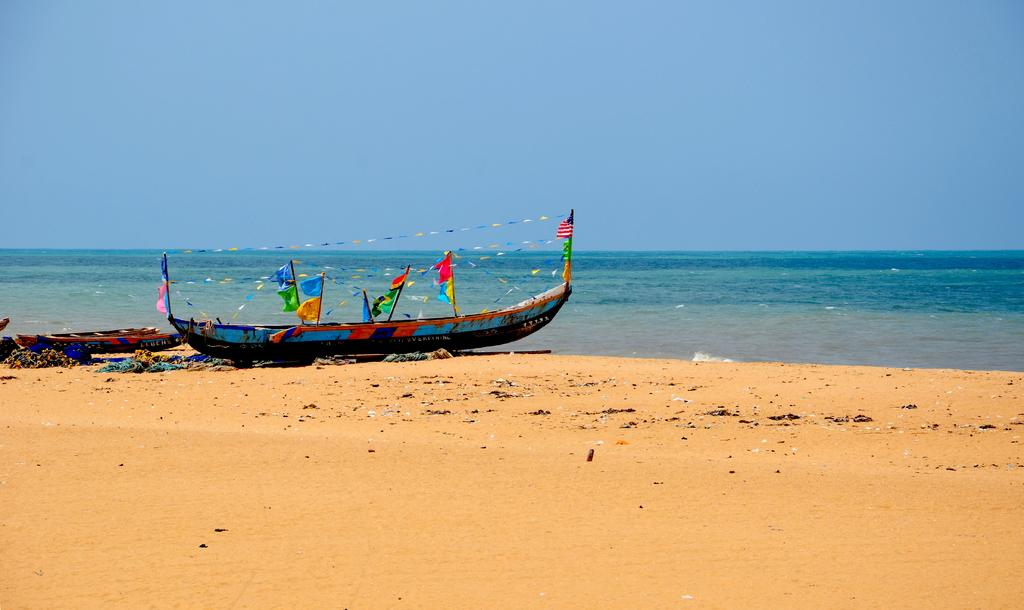What type of vehicles are on the sand in the image? There are boats on the sand in the image. What can be inferred about the location of the image based on the presence of boats and sand? The image appears to be taken near a sea or ocean. What is visible at the top of the image? The sky is visible at the top of the image. What is the weather like in the image? The sky appears to be sunny, suggesting a clear and bright day. Who is the manager of the boats in the image? There is no information about a manager in the image, as it only shows boats on the sand near a sea. 